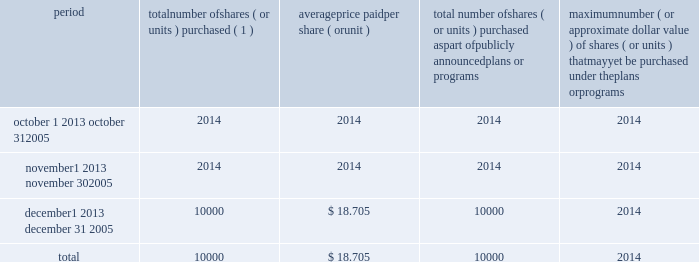The amount available to us to pay cash dividends is restricted by our subsidiaries 2019 debt agreements .
The indentures governing the senior subordinated notes and the senior discount notes also limit , but do not prohibit , the ability of bcp crystal , crystal llc and their respective subsidiaries to pay dividends .
Any decision to declare and pay dividends in the future will be made at the discretion of our board of directors and will depend on , among other things , our results of operations , cash requirements , financial condition , contractual restrictions and other factors that our board of directors may deem relevant .
Under the domination agreement , any minority shareholder of celanese ag who elects not to sell its shares to the purchaser will be entitled to remain a shareholder of celanese ag and to receive a gross guaranteed fixed annual payment on their shares of u3.27 per celanese share less certain corporate taxes to be paid by cag in lieu of any future dividend .
See 2018 2018the transactions 2014 post-tender offer events 2014domination and profit and loss transfer agreement . 2019 2019 under delaware law , our board of directors may declare dividends only to the extent of our 2018 2018surplus 2019 2019 ( which is defined as total assets at fair market value minus total liabilities , minus statutory capital ) , or if there is no surplus , out of our net profits for the then current and/or immediately preceding fiscal years .
The value of a corporation 2019s assets can be measured in a number of ways and may not necessarily equal their book value .
The value of our capital may be adjusted from time to time by our board of directors but in no event will be less than the aggregate par value of our issued stock .
Our board of directors may base this determination on our financial statements , a fair valuation of our assets or another reasonable method .
Our board of directors will seek to assure itself that the statutory requirements will be met before actually declaring dividends .
In future periods , our board of directors may seek opinions from outside valuation firms to the effect that our solvency or assets are sufficient to allow payment of dividends , and such opinions may not be forthcoming .
If we sought and were not able to obtain such an opinion , we likely would not be able to pay dividends .
In addition , pursuant to the terms of our preferred stock , we are prohibited from paying a dividend on our series a common stock unless all payments due and payable under the preferred stock have been made .
Celanese purchases of its equity securities period number of shares ( or units ) purchased ( 1 ) average price paid per share ( or unit ) total number of shares ( or units ) purchased as part of publicly announced plans or programs maximum number ( or approximate dollar value ) of shares ( or units ) that may yet be purchased under the plans or programs october 1 2013 october 31 , 2005 2014 2014 2014 2014 november 1 2013 november 30 , 2005 2014 2014 2014 2014 december 1 2013 december 31 , 2005 10000 $ 18.705 10000 2014 .
( 1 ) 10000 shares of series a common stock were purchased on the open market in december 2005 at $ 18.705 per share , approved by the board of directors pursuant to the provisions of the 2004 stock incentive plan , approved by shareholders in december 2004 , to be granted to two employees in recognition of their contributions to the company .
No other purchases are currently planned .
Equity compensation plans the information required to be included in this item 5 with respect to our equity compensation plans is incorporated by reference from the section captioned 2018 2018securities authorized for issuance under equity compensation plans 2019 2019 in the company 2019s definitive proxy statement for the 2006 annual meeting of stockholders .
Recent sales of unregistered securities .
What is the total amount spent for the purchased shares during december 2005? 
Computations: (10000 * 18.705)
Answer: 187050.0. The amount available to us to pay cash dividends is restricted by our subsidiaries 2019 debt agreements .
The indentures governing the senior subordinated notes and the senior discount notes also limit , but do not prohibit , the ability of bcp crystal , crystal llc and their respective subsidiaries to pay dividends .
Any decision to declare and pay dividends in the future will be made at the discretion of our board of directors and will depend on , among other things , our results of operations , cash requirements , financial condition , contractual restrictions and other factors that our board of directors may deem relevant .
Under the domination agreement , any minority shareholder of celanese ag who elects not to sell its shares to the purchaser will be entitled to remain a shareholder of celanese ag and to receive a gross guaranteed fixed annual payment on their shares of u3.27 per celanese share less certain corporate taxes to be paid by cag in lieu of any future dividend .
See 2018 2018the transactions 2014 post-tender offer events 2014domination and profit and loss transfer agreement . 2019 2019 under delaware law , our board of directors may declare dividends only to the extent of our 2018 2018surplus 2019 2019 ( which is defined as total assets at fair market value minus total liabilities , minus statutory capital ) , or if there is no surplus , out of our net profits for the then current and/or immediately preceding fiscal years .
The value of a corporation 2019s assets can be measured in a number of ways and may not necessarily equal their book value .
The value of our capital may be adjusted from time to time by our board of directors but in no event will be less than the aggregate par value of our issued stock .
Our board of directors may base this determination on our financial statements , a fair valuation of our assets or another reasonable method .
Our board of directors will seek to assure itself that the statutory requirements will be met before actually declaring dividends .
In future periods , our board of directors may seek opinions from outside valuation firms to the effect that our solvency or assets are sufficient to allow payment of dividends , and such opinions may not be forthcoming .
If we sought and were not able to obtain such an opinion , we likely would not be able to pay dividends .
In addition , pursuant to the terms of our preferred stock , we are prohibited from paying a dividend on our series a common stock unless all payments due and payable under the preferred stock have been made .
Celanese purchases of its equity securities period number of shares ( or units ) purchased ( 1 ) average price paid per share ( or unit ) total number of shares ( or units ) purchased as part of publicly announced plans or programs maximum number ( or approximate dollar value ) of shares ( or units ) that may yet be purchased under the plans or programs october 1 2013 october 31 , 2005 2014 2014 2014 2014 november 1 2013 november 30 , 2005 2014 2014 2014 2014 december 1 2013 december 31 , 2005 10000 $ 18.705 10000 2014 .
( 1 ) 10000 shares of series a common stock were purchased on the open market in december 2005 at $ 18.705 per share , approved by the board of directors pursuant to the provisions of the 2004 stock incentive plan , approved by shareholders in december 2004 , to be granted to two employees in recognition of their contributions to the company .
No other purchases are currently planned .
Equity compensation plans the information required to be included in this item 5 with respect to our equity compensation plans is incorporated by reference from the section captioned 2018 2018securities authorized for issuance under equity compensation plans 2019 2019 in the company 2019s definitive proxy statement for the 2006 annual meeting of stockholders .
Recent sales of unregistered securities .
What was the cost of the shares of series a common stock were purchased on the open market in december 2005? 
Computations: (10000 * 18.705)
Answer: 187050.0. 